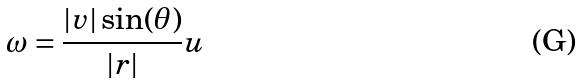<formula> <loc_0><loc_0><loc_500><loc_500>\omega = \frac { | v | \sin ( \theta ) } { | r | } u</formula> 